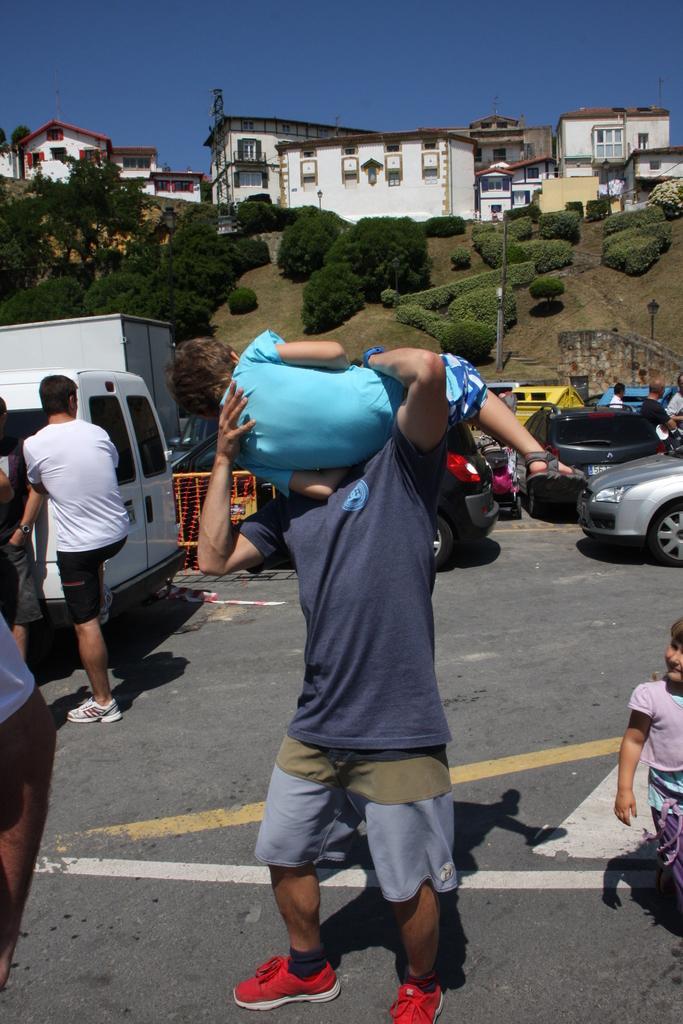Please provide a concise description of this image. In the background we can see the sky, buildings. In this picture we can see grass, trees, plants, poles and objects. We can see the people and vehicles. We can see a man lifting a boy and standing on the road. 